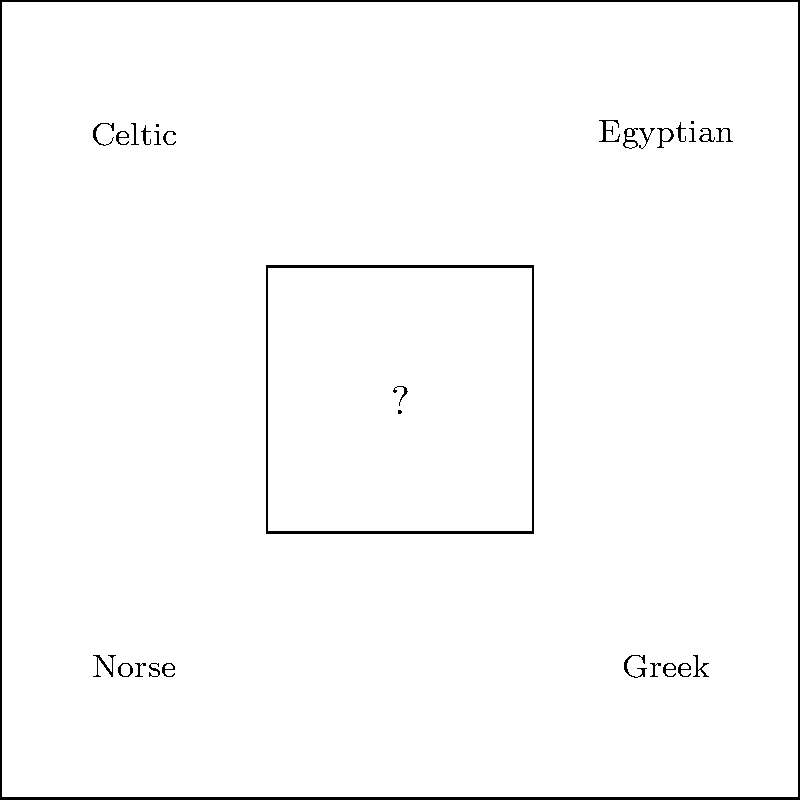Based on the linguistic connections between mythologies, which mythological tradition should be placed in the center of the diagram to represent a common Indo-European origin shared by the surrounding mythologies? To answer this question, we need to consider the linguistic relationships between the mythologies presented:

1. Norse, Greek, and Celtic mythologies are all part of the Indo-European language family.
2. Egyptian mythology, while influential, belongs to the Afroasiatic language family.
3. The Indo-European language family is believed to have a common ancestor, called Proto-Indo-European (PIE).
4. Sanskrit, the ancient language of India, is one of the oldest attested Indo-European languages and is closely related to PIE.
5. Hindu mythology, expressed in Sanskrit texts, shares many linguistic and thematic connections with other Indo-European mythologies.
6. The central position in the diagram suggests a unifying or ancestral role among the surrounding mythologies.

Given these factors, Hindu mythology, represented by Sanskrit, would be the most appropriate to place in the center. It serves as a linguistic bridge between the Indo-European mythologies surrounding it (Norse, Greek, and Celtic) while also having historical connections to Egyptian mythology through cultural exchange.
Answer: Hindu 